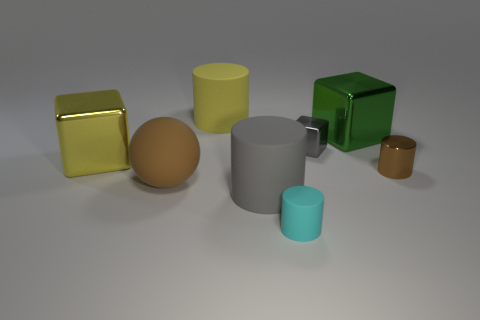Is the matte ball the same color as the metallic cylinder?
Give a very brief answer. Yes. The small shiny thing that is the same color as the matte sphere is what shape?
Your answer should be compact. Cylinder. Is there anything else that has the same shape as the large brown thing?
Your answer should be very brief. No. Are there the same number of green metal things that are in front of the tiny brown metallic cylinder and large brown metallic cylinders?
Your response must be concise. Yes. What number of cylinders are in front of the big green metallic object and on the left side of the green metal object?
Give a very brief answer. 2. The brown shiny thing that is the same shape as the cyan rubber thing is what size?
Keep it short and to the point. Small. How many gray cylinders are made of the same material as the tiny cyan object?
Your answer should be compact. 1. Are there fewer cubes that are to the right of the small gray metal thing than small shiny objects?
Make the answer very short. Yes. How many cyan cylinders are there?
Provide a short and direct response. 1. What number of cylinders have the same color as the sphere?
Give a very brief answer. 1. 